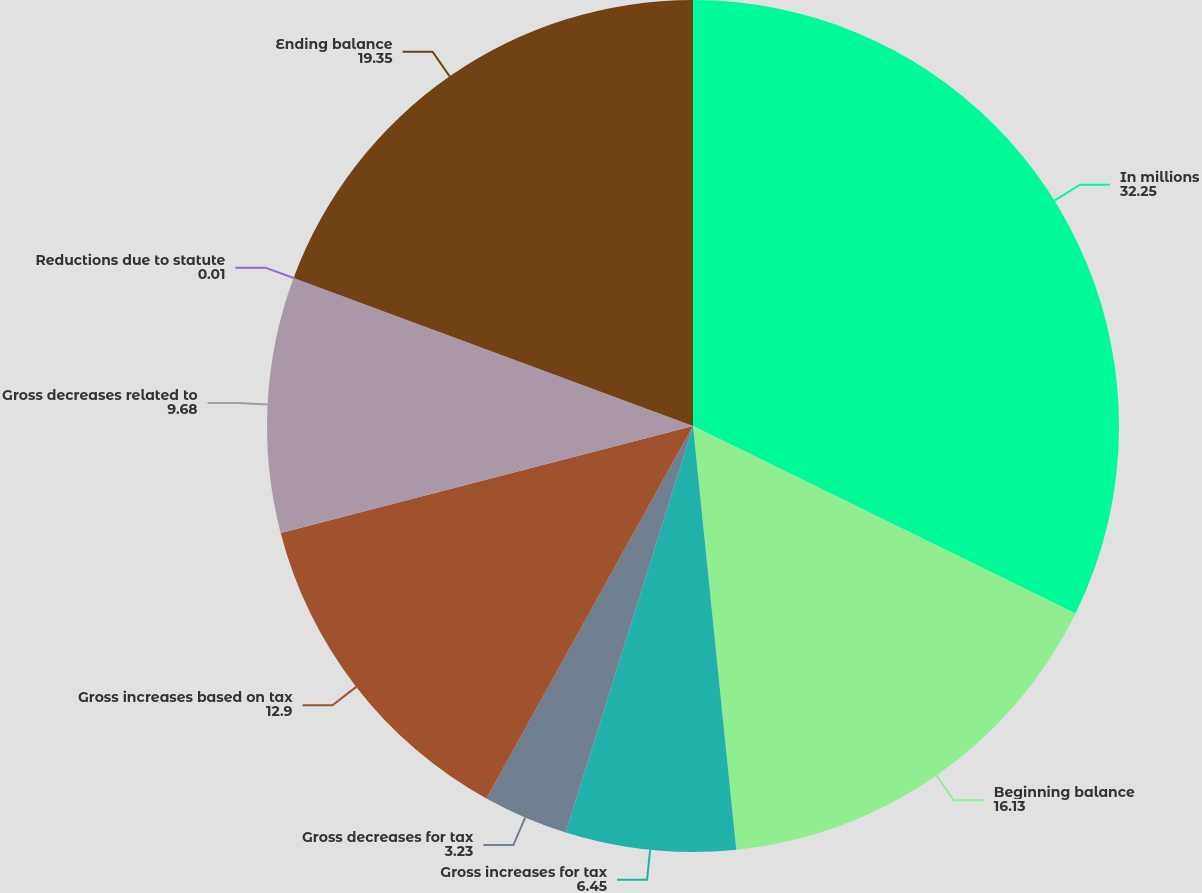Convert chart. <chart><loc_0><loc_0><loc_500><loc_500><pie_chart><fcel>In millions<fcel>Beginning balance<fcel>Gross increases for tax<fcel>Gross decreases for tax<fcel>Gross increases based on tax<fcel>Gross decreases related to<fcel>Reductions due to statute<fcel>Ending balance<nl><fcel>32.25%<fcel>16.13%<fcel>6.45%<fcel>3.23%<fcel>12.9%<fcel>9.68%<fcel>0.01%<fcel>19.35%<nl></chart> 